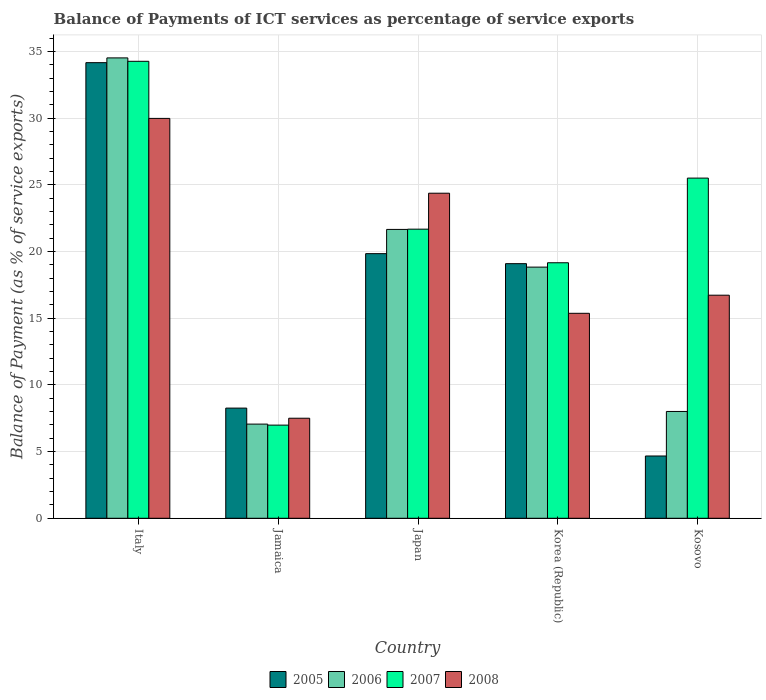How many different coloured bars are there?
Make the answer very short. 4. Are the number of bars on each tick of the X-axis equal?
Keep it short and to the point. Yes. How many bars are there on the 5th tick from the right?
Offer a terse response. 4. What is the label of the 1st group of bars from the left?
Your answer should be very brief. Italy. What is the balance of payments of ICT services in 2008 in Kosovo?
Ensure brevity in your answer.  16.73. Across all countries, what is the maximum balance of payments of ICT services in 2007?
Offer a terse response. 34.28. Across all countries, what is the minimum balance of payments of ICT services in 2005?
Keep it short and to the point. 4.67. In which country was the balance of payments of ICT services in 2006 maximum?
Make the answer very short. Italy. In which country was the balance of payments of ICT services in 2007 minimum?
Make the answer very short. Jamaica. What is the total balance of payments of ICT services in 2008 in the graph?
Your response must be concise. 93.99. What is the difference between the balance of payments of ICT services in 2007 in Jamaica and that in Korea (Republic)?
Provide a short and direct response. -12.18. What is the difference between the balance of payments of ICT services in 2008 in Japan and the balance of payments of ICT services in 2006 in Italy?
Your answer should be compact. -10.15. What is the average balance of payments of ICT services in 2005 per country?
Your response must be concise. 17.21. What is the difference between the balance of payments of ICT services of/in 2006 and balance of payments of ICT services of/in 2005 in Japan?
Offer a terse response. 1.82. In how many countries, is the balance of payments of ICT services in 2007 greater than 16 %?
Keep it short and to the point. 4. What is the ratio of the balance of payments of ICT services in 2005 in Jamaica to that in Japan?
Your answer should be very brief. 0.42. Is the difference between the balance of payments of ICT services in 2006 in Japan and Kosovo greater than the difference between the balance of payments of ICT services in 2005 in Japan and Kosovo?
Provide a succinct answer. No. What is the difference between the highest and the second highest balance of payments of ICT services in 2008?
Your answer should be compact. 7.65. What is the difference between the highest and the lowest balance of payments of ICT services in 2005?
Provide a succinct answer. 29.5. Is the sum of the balance of payments of ICT services in 2006 in Japan and Kosovo greater than the maximum balance of payments of ICT services in 2007 across all countries?
Your response must be concise. No. Is it the case that in every country, the sum of the balance of payments of ICT services in 2005 and balance of payments of ICT services in 2008 is greater than the sum of balance of payments of ICT services in 2007 and balance of payments of ICT services in 2006?
Your response must be concise. No. How many countries are there in the graph?
Your answer should be compact. 5. What is the difference between two consecutive major ticks on the Y-axis?
Make the answer very short. 5. Does the graph contain any zero values?
Your answer should be compact. No. Does the graph contain grids?
Ensure brevity in your answer.  Yes. Where does the legend appear in the graph?
Make the answer very short. Bottom center. How are the legend labels stacked?
Give a very brief answer. Horizontal. What is the title of the graph?
Your answer should be very brief. Balance of Payments of ICT services as percentage of service exports. What is the label or title of the Y-axis?
Your answer should be very brief. Balance of Payment (as % of service exports). What is the Balance of Payment (as % of service exports) in 2005 in Italy?
Ensure brevity in your answer.  34.17. What is the Balance of Payment (as % of service exports) of 2006 in Italy?
Offer a very short reply. 34.53. What is the Balance of Payment (as % of service exports) of 2007 in Italy?
Make the answer very short. 34.28. What is the Balance of Payment (as % of service exports) in 2008 in Italy?
Ensure brevity in your answer.  29.99. What is the Balance of Payment (as % of service exports) in 2005 in Jamaica?
Give a very brief answer. 8.26. What is the Balance of Payment (as % of service exports) in 2006 in Jamaica?
Provide a succinct answer. 7.06. What is the Balance of Payment (as % of service exports) of 2007 in Jamaica?
Offer a very short reply. 6.99. What is the Balance of Payment (as % of service exports) in 2008 in Jamaica?
Offer a very short reply. 7.5. What is the Balance of Payment (as % of service exports) of 2005 in Japan?
Ensure brevity in your answer.  19.85. What is the Balance of Payment (as % of service exports) of 2006 in Japan?
Provide a short and direct response. 21.67. What is the Balance of Payment (as % of service exports) of 2007 in Japan?
Provide a succinct answer. 21.69. What is the Balance of Payment (as % of service exports) of 2008 in Japan?
Offer a terse response. 24.38. What is the Balance of Payment (as % of service exports) in 2005 in Korea (Republic)?
Offer a very short reply. 19.1. What is the Balance of Payment (as % of service exports) in 2006 in Korea (Republic)?
Provide a short and direct response. 18.84. What is the Balance of Payment (as % of service exports) of 2007 in Korea (Republic)?
Provide a short and direct response. 19.16. What is the Balance of Payment (as % of service exports) in 2008 in Korea (Republic)?
Your answer should be very brief. 15.37. What is the Balance of Payment (as % of service exports) of 2005 in Kosovo?
Your answer should be compact. 4.67. What is the Balance of Payment (as % of service exports) of 2006 in Kosovo?
Your answer should be very brief. 8.01. What is the Balance of Payment (as % of service exports) in 2007 in Kosovo?
Your response must be concise. 25.51. What is the Balance of Payment (as % of service exports) in 2008 in Kosovo?
Keep it short and to the point. 16.73. Across all countries, what is the maximum Balance of Payment (as % of service exports) of 2005?
Give a very brief answer. 34.17. Across all countries, what is the maximum Balance of Payment (as % of service exports) in 2006?
Make the answer very short. 34.53. Across all countries, what is the maximum Balance of Payment (as % of service exports) in 2007?
Your answer should be compact. 34.28. Across all countries, what is the maximum Balance of Payment (as % of service exports) in 2008?
Offer a very short reply. 29.99. Across all countries, what is the minimum Balance of Payment (as % of service exports) in 2005?
Your answer should be very brief. 4.67. Across all countries, what is the minimum Balance of Payment (as % of service exports) of 2006?
Provide a succinct answer. 7.06. Across all countries, what is the minimum Balance of Payment (as % of service exports) of 2007?
Your response must be concise. 6.99. Across all countries, what is the minimum Balance of Payment (as % of service exports) in 2008?
Keep it short and to the point. 7.5. What is the total Balance of Payment (as % of service exports) in 2005 in the graph?
Offer a very short reply. 86.05. What is the total Balance of Payment (as % of service exports) of 2006 in the graph?
Make the answer very short. 90.11. What is the total Balance of Payment (as % of service exports) in 2007 in the graph?
Offer a terse response. 107.63. What is the total Balance of Payment (as % of service exports) in 2008 in the graph?
Your answer should be very brief. 93.99. What is the difference between the Balance of Payment (as % of service exports) of 2005 in Italy and that in Jamaica?
Provide a succinct answer. 25.91. What is the difference between the Balance of Payment (as % of service exports) in 2006 in Italy and that in Jamaica?
Provide a short and direct response. 27.47. What is the difference between the Balance of Payment (as % of service exports) in 2007 in Italy and that in Jamaica?
Offer a terse response. 27.29. What is the difference between the Balance of Payment (as % of service exports) of 2008 in Italy and that in Jamaica?
Provide a succinct answer. 22.49. What is the difference between the Balance of Payment (as % of service exports) of 2005 in Italy and that in Japan?
Provide a succinct answer. 14.33. What is the difference between the Balance of Payment (as % of service exports) of 2006 in Italy and that in Japan?
Provide a short and direct response. 12.87. What is the difference between the Balance of Payment (as % of service exports) of 2007 in Italy and that in Japan?
Make the answer very short. 12.59. What is the difference between the Balance of Payment (as % of service exports) in 2008 in Italy and that in Japan?
Keep it short and to the point. 5.61. What is the difference between the Balance of Payment (as % of service exports) in 2005 in Italy and that in Korea (Republic)?
Provide a short and direct response. 15.08. What is the difference between the Balance of Payment (as % of service exports) of 2006 in Italy and that in Korea (Republic)?
Make the answer very short. 15.69. What is the difference between the Balance of Payment (as % of service exports) in 2007 in Italy and that in Korea (Republic)?
Your response must be concise. 15.11. What is the difference between the Balance of Payment (as % of service exports) in 2008 in Italy and that in Korea (Republic)?
Give a very brief answer. 14.62. What is the difference between the Balance of Payment (as % of service exports) of 2005 in Italy and that in Kosovo?
Your response must be concise. 29.5. What is the difference between the Balance of Payment (as % of service exports) of 2006 in Italy and that in Kosovo?
Offer a very short reply. 26.52. What is the difference between the Balance of Payment (as % of service exports) of 2007 in Italy and that in Kosovo?
Offer a very short reply. 8.76. What is the difference between the Balance of Payment (as % of service exports) of 2008 in Italy and that in Kosovo?
Keep it short and to the point. 13.26. What is the difference between the Balance of Payment (as % of service exports) in 2005 in Jamaica and that in Japan?
Make the answer very short. -11.59. What is the difference between the Balance of Payment (as % of service exports) in 2006 in Jamaica and that in Japan?
Offer a very short reply. -14.6. What is the difference between the Balance of Payment (as % of service exports) of 2007 in Jamaica and that in Japan?
Provide a short and direct response. -14.7. What is the difference between the Balance of Payment (as % of service exports) of 2008 in Jamaica and that in Japan?
Offer a very short reply. -16.88. What is the difference between the Balance of Payment (as % of service exports) in 2005 in Jamaica and that in Korea (Republic)?
Your answer should be very brief. -10.83. What is the difference between the Balance of Payment (as % of service exports) in 2006 in Jamaica and that in Korea (Republic)?
Give a very brief answer. -11.78. What is the difference between the Balance of Payment (as % of service exports) of 2007 in Jamaica and that in Korea (Republic)?
Your answer should be compact. -12.18. What is the difference between the Balance of Payment (as % of service exports) in 2008 in Jamaica and that in Korea (Republic)?
Provide a succinct answer. -7.87. What is the difference between the Balance of Payment (as % of service exports) in 2005 in Jamaica and that in Kosovo?
Your answer should be compact. 3.59. What is the difference between the Balance of Payment (as % of service exports) of 2006 in Jamaica and that in Kosovo?
Your answer should be very brief. -0.95. What is the difference between the Balance of Payment (as % of service exports) in 2007 in Jamaica and that in Kosovo?
Keep it short and to the point. -18.53. What is the difference between the Balance of Payment (as % of service exports) of 2008 in Jamaica and that in Kosovo?
Your answer should be very brief. -9.23. What is the difference between the Balance of Payment (as % of service exports) in 2005 in Japan and that in Korea (Republic)?
Keep it short and to the point. 0.75. What is the difference between the Balance of Payment (as % of service exports) of 2006 in Japan and that in Korea (Republic)?
Offer a very short reply. 2.83. What is the difference between the Balance of Payment (as % of service exports) in 2007 in Japan and that in Korea (Republic)?
Ensure brevity in your answer.  2.52. What is the difference between the Balance of Payment (as % of service exports) in 2008 in Japan and that in Korea (Republic)?
Your answer should be very brief. 9.01. What is the difference between the Balance of Payment (as % of service exports) of 2005 in Japan and that in Kosovo?
Provide a succinct answer. 15.18. What is the difference between the Balance of Payment (as % of service exports) of 2006 in Japan and that in Kosovo?
Your response must be concise. 13.66. What is the difference between the Balance of Payment (as % of service exports) in 2007 in Japan and that in Kosovo?
Ensure brevity in your answer.  -3.83. What is the difference between the Balance of Payment (as % of service exports) of 2008 in Japan and that in Kosovo?
Make the answer very short. 7.65. What is the difference between the Balance of Payment (as % of service exports) in 2005 in Korea (Republic) and that in Kosovo?
Provide a succinct answer. 14.43. What is the difference between the Balance of Payment (as % of service exports) in 2006 in Korea (Republic) and that in Kosovo?
Keep it short and to the point. 10.83. What is the difference between the Balance of Payment (as % of service exports) of 2007 in Korea (Republic) and that in Kosovo?
Your answer should be compact. -6.35. What is the difference between the Balance of Payment (as % of service exports) in 2008 in Korea (Republic) and that in Kosovo?
Give a very brief answer. -1.36. What is the difference between the Balance of Payment (as % of service exports) in 2005 in Italy and the Balance of Payment (as % of service exports) in 2006 in Jamaica?
Your answer should be compact. 27.11. What is the difference between the Balance of Payment (as % of service exports) in 2005 in Italy and the Balance of Payment (as % of service exports) in 2007 in Jamaica?
Your answer should be very brief. 27.19. What is the difference between the Balance of Payment (as % of service exports) in 2005 in Italy and the Balance of Payment (as % of service exports) in 2008 in Jamaica?
Your answer should be very brief. 26.67. What is the difference between the Balance of Payment (as % of service exports) in 2006 in Italy and the Balance of Payment (as % of service exports) in 2007 in Jamaica?
Ensure brevity in your answer.  27.54. What is the difference between the Balance of Payment (as % of service exports) of 2006 in Italy and the Balance of Payment (as % of service exports) of 2008 in Jamaica?
Ensure brevity in your answer.  27.03. What is the difference between the Balance of Payment (as % of service exports) of 2007 in Italy and the Balance of Payment (as % of service exports) of 2008 in Jamaica?
Your response must be concise. 26.77. What is the difference between the Balance of Payment (as % of service exports) in 2005 in Italy and the Balance of Payment (as % of service exports) in 2006 in Japan?
Offer a terse response. 12.51. What is the difference between the Balance of Payment (as % of service exports) of 2005 in Italy and the Balance of Payment (as % of service exports) of 2007 in Japan?
Provide a short and direct response. 12.49. What is the difference between the Balance of Payment (as % of service exports) of 2005 in Italy and the Balance of Payment (as % of service exports) of 2008 in Japan?
Provide a short and direct response. 9.79. What is the difference between the Balance of Payment (as % of service exports) of 2006 in Italy and the Balance of Payment (as % of service exports) of 2007 in Japan?
Offer a terse response. 12.85. What is the difference between the Balance of Payment (as % of service exports) of 2006 in Italy and the Balance of Payment (as % of service exports) of 2008 in Japan?
Offer a very short reply. 10.15. What is the difference between the Balance of Payment (as % of service exports) of 2007 in Italy and the Balance of Payment (as % of service exports) of 2008 in Japan?
Your answer should be compact. 9.89. What is the difference between the Balance of Payment (as % of service exports) in 2005 in Italy and the Balance of Payment (as % of service exports) in 2006 in Korea (Republic)?
Offer a terse response. 15.34. What is the difference between the Balance of Payment (as % of service exports) of 2005 in Italy and the Balance of Payment (as % of service exports) of 2007 in Korea (Republic)?
Your answer should be very brief. 15.01. What is the difference between the Balance of Payment (as % of service exports) of 2005 in Italy and the Balance of Payment (as % of service exports) of 2008 in Korea (Republic)?
Your answer should be very brief. 18.8. What is the difference between the Balance of Payment (as % of service exports) in 2006 in Italy and the Balance of Payment (as % of service exports) in 2007 in Korea (Republic)?
Ensure brevity in your answer.  15.37. What is the difference between the Balance of Payment (as % of service exports) in 2006 in Italy and the Balance of Payment (as % of service exports) in 2008 in Korea (Republic)?
Your answer should be compact. 19.16. What is the difference between the Balance of Payment (as % of service exports) of 2007 in Italy and the Balance of Payment (as % of service exports) of 2008 in Korea (Republic)?
Offer a very short reply. 18.9. What is the difference between the Balance of Payment (as % of service exports) in 2005 in Italy and the Balance of Payment (as % of service exports) in 2006 in Kosovo?
Offer a terse response. 26.16. What is the difference between the Balance of Payment (as % of service exports) in 2005 in Italy and the Balance of Payment (as % of service exports) in 2007 in Kosovo?
Keep it short and to the point. 8.66. What is the difference between the Balance of Payment (as % of service exports) in 2005 in Italy and the Balance of Payment (as % of service exports) in 2008 in Kosovo?
Ensure brevity in your answer.  17.44. What is the difference between the Balance of Payment (as % of service exports) of 2006 in Italy and the Balance of Payment (as % of service exports) of 2007 in Kosovo?
Provide a succinct answer. 9.02. What is the difference between the Balance of Payment (as % of service exports) of 2006 in Italy and the Balance of Payment (as % of service exports) of 2008 in Kosovo?
Provide a short and direct response. 17.8. What is the difference between the Balance of Payment (as % of service exports) in 2007 in Italy and the Balance of Payment (as % of service exports) in 2008 in Kosovo?
Offer a terse response. 17.54. What is the difference between the Balance of Payment (as % of service exports) in 2005 in Jamaica and the Balance of Payment (as % of service exports) in 2006 in Japan?
Your answer should be compact. -13.4. What is the difference between the Balance of Payment (as % of service exports) of 2005 in Jamaica and the Balance of Payment (as % of service exports) of 2007 in Japan?
Offer a very short reply. -13.42. What is the difference between the Balance of Payment (as % of service exports) of 2005 in Jamaica and the Balance of Payment (as % of service exports) of 2008 in Japan?
Offer a terse response. -16.12. What is the difference between the Balance of Payment (as % of service exports) in 2006 in Jamaica and the Balance of Payment (as % of service exports) in 2007 in Japan?
Keep it short and to the point. -14.62. What is the difference between the Balance of Payment (as % of service exports) in 2006 in Jamaica and the Balance of Payment (as % of service exports) in 2008 in Japan?
Offer a terse response. -17.32. What is the difference between the Balance of Payment (as % of service exports) of 2007 in Jamaica and the Balance of Payment (as % of service exports) of 2008 in Japan?
Your answer should be very brief. -17.39. What is the difference between the Balance of Payment (as % of service exports) of 2005 in Jamaica and the Balance of Payment (as % of service exports) of 2006 in Korea (Republic)?
Make the answer very short. -10.58. What is the difference between the Balance of Payment (as % of service exports) in 2005 in Jamaica and the Balance of Payment (as % of service exports) in 2007 in Korea (Republic)?
Provide a short and direct response. -10.9. What is the difference between the Balance of Payment (as % of service exports) of 2005 in Jamaica and the Balance of Payment (as % of service exports) of 2008 in Korea (Republic)?
Offer a terse response. -7.11. What is the difference between the Balance of Payment (as % of service exports) of 2006 in Jamaica and the Balance of Payment (as % of service exports) of 2007 in Korea (Republic)?
Make the answer very short. -12.1. What is the difference between the Balance of Payment (as % of service exports) in 2006 in Jamaica and the Balance of Payment (as % of service exports) in 2008 in Korea (Republic)?
Keep it short and to the point. -8.31. What is the difference between the Balance of Payment (as % of service exports) of 2007 in Jamaica and the Balance of Payment (as % of service exports) of 2008 in Korea (Republic)?
Your answer should be very brief. -8.39. What is the difference between the Balance of Payment (as % of service exports) in 2005 in Jamaica and the Balance of Payment (as % of service exports) in 2006 in Kosovo?
Your answer should be compact. 0.25. What is the difference between the Balance of Payment (as % of service exports) of 2005 in Jamaica and the Balance of Payment (as % of service exports) of 2007 in Kosovo?
Your answer should be compact. -17.25. What is the difference between the Balance of Payment (as % of service exports) of 2005 in Jamaica and the Balance of Payment (as % of service exports) of 2008 in Kosovo?
Keep it short and to the point. -8.47. What is the difference between the Balance of Payment (as % of service exports) in 2006 in Jamaica and the Balance of Payment (as % of service exports) in 2007 in Kosovo?
Offer a very short reply. -18.45. What is the difference between the Balance of Payment (as % of service exports) of 2006 in Jamaica and the Balance of Payment (as % of service exports) of 2008 in Kosovo?
Your answer should be very brief. -9.67. What is the difference between the Balance of Payment (as % of service exports) in 2007 in Jamaica and the Balance of Payment (as % of service exports) in 2008 in Kosovo?
Your answer should be very brief. -9.74. What is the difference between the Balance of Payment (as % of service exports) of 2005 in Japan and the Balance of Payment (as % of service exports) of 2006 in Korea (Republic)?
Provide a short and direct response. 1.01. What is the difference between the Balance of Payment (as % of service exports) of 2005 in Japan and the Balance of Payment (as % of service exports) of 2007 in Korea (Republic)?
Provide a short and direct response. 0.68. What is the difference between the Balance of Payment (as % of service exports) in 2005 in Japan and the Balance of Payment (as % of service exports) in 2008 in Korea (Republic)?
Provide a short and direct response. 4.48. What is the difference between the Balance of Payment (as % of service exports) of 2006 in Japan and the Balance of Payment (as % of service exports) of 2007 in Korea (Republic)?
Offer a very short reply. 2.5. What is the difference between the Balance of Payment (as % of service exports) in 2006 in Japan and the Balance of Payment (as % of service exports) in 2008 in Korea (Republic)?
Provide a succinct answer. 6.29. What is the difference between the Balance of Payment (as % of service exports) of 2007 in Japan and the Balance of Payment (as % of service exports) of 2008 in Korea (Republic)?
Give a very brief answer. 6.31. What is the difference between the Balance of Payment (as % of service exports) in 2005 in Japan and the Balance of Payment (as % of service exports) in 2006 in Kosovo?
Your response must be concise. 11.84. What is the difference between the Balance of Payment (as % of service exports) in 2005 in Japan and the Balance of Payment (as % of service exports) in 2007 in Kosovo?
Your answer should be compact. -5.67. What is the difference between the Balance of Payment (as % of service exports) of 2005 in Japan and the Balance of Payment (as % of service exports) of 2008 in Kosovo?
Your answer should be compact. 3.12. What is the difference between the Balance of Payment (as % of service exports) of 2006 in Japan and the Balance of Payment (as % of service exports) of 2007 in Kosovo?
Your answer should be compact. -3.85. What is the difference between the Balance of Payment (as % of service exports) of 2006 in Japan and the Balance of Payment (as % of service exports) of 2008 in Kosovo?
Provide a short and direct response. 4.93. What is the difference between the Balance of Payment (as % of service exports) of 2007 in Japan and the Balance of Payment (as % of service exports) of 2008 in Kosovo?
Your answer should be compact. 4.95. What is the difference between the Balance of Payment (as % of service exports) in 2005 in Korea (Republic) and the Balance of Payment (as % of service exports) in 2006 in Kosovo?
Your answer should be compact. 11.09. What is the difference between the Balance of Payment (as % of service exports) of 2005 in Korea (Republic) and the Balance of Payment (as % of service exports) of 2007 in Kosovo?
Your answer should be very brief. -6.42. What is the difference between the Balance of Payment (as % of service exports) of 2005 in Korea (Republic) and the Balance of Payment (as % of service exports) of 2008 in Kosovo?
Offer a terse response. 2.37. What is the difference between the Balance of Payment (as % of service exports) in 2006 in Korea (Republic) and the Balance of Payment (as % of service exports) in 2007 in Kosovo?
Your answer should be very brief. -6.68. What is the difference between the Balance of Payment (as % of service exports) in 2006 in Korea (Republic) and the Balance of Payment (as % of service exports) in 2008 in Kosovo?
Provide a short and direct response. 2.11. What is the difference between the Balance of Payment (as % of service exports) of 2007 in Korea (Republic) and the Balance of Payment (as % of service exports) of 2008 in Kosovo?
Provide a short and direct response. 2.43. What is the average Balance of Payment (as % of service exports) of 2005 per country?
Make the answer very short. 17.21. What is the average Balance of Payment (as % of service exports) of 2006 per country?
Offer a very short reply. 18.02. What is the average Balance of Payment (as % of service exports) of 2007 per country?
Make the answer very short. 21.53. What is the average Balance of Payment (as % of service exports) of 2008 per country?
Your answer should be very brief. 18.8. What is the difference between the Balance of Payment (as % of service exports) in 2005 and Balance of Payment (as % of service exports) in 2006 in Italy?
Your answer should be compact. -0.36. What is the difference between the Balance of Payment (as % of service exports) in 2005 and Balance of Payment (as % of service exports) in 2007 in Italy?
Ensure brevity in your answer.  -0.1. What is the difference between the Balance of Payment (as % of service exports) in 2005 and Balance of Payment (as % of service exports) in 2008 in Italy?
Ensure brevity in your answer.  4.18. What is the difference between the Balance of Payment (as % of service exports) in 2006 and Balance of Payment (as % of service exports) in 2007 in Italy?
Ensure brevity in your answer.  0.26. What is the difference between the Balance of Payment (as % of service exports) in 2006 and Balance of Payment (as % of service exports) in 2008 in Italy?
Provide a short and direct response. 4.54. What is the difference between the Balance of Payment (as % of service exports) in 2007 and Balance of Payment (as % of service exports) in 2008 in Italy?
Your answer should be compact. 4.28. What is the difference between the Balance of Payment (as % of service exports) in 2005 and Balance of Payment (as % of service exports) in 2006 in Jamaica?
Ensure brevity in your answer.  1.2. What is the difference between the Balance of Payment (as % of service exports) of 2005 and Balance of Payment (as % of service exports) of 2007 in Jamaica?
Ensure brevity in your answer.  1.28. What is the difference between the Balance of Payment (as % of service exports) in 2005 and Balance of Payment (as % of service exports) in 2008 in Jamaica?
Provide a succinct answer. 0.76. What is the difference between the Balance of Payment (as % of service exports) of 2006 and Balance of Payment (as % of service exports) of 2007 in Jamaica?
Offer a very short reply. 0.08. What is the difference between the Balance of Payment (as % of service exports) of 2006 and Balance of Payment (as % of service exports) of 2008 in Jamaica?
Your response must be concise. -0.44. What is the difference between the Balance of Payment (as % of service exports) of 2007 and Balance of Payment (as % of service exports) of 2008 in Jamaica?
Give a very brief answer. -0.52. What is the difference between the Balance of Payment (as % of service exports) of 2005 and Balance of Payment (as % of service exports) of 2006 in Japan?
Provide a succinct answer. -1.82. What is the difference between the Balance of Payment (as % of service exports) of 2005 and Balance of Payment (as % of service exports) of 2007 in Japan?
Offer a terse response. -1.84. What is the difference between the Balance of Payment (as % of service exports) of 2005 and Balance of Payment (as % of service exports) of 2008 in Japan?
Make the answer very short. -4.53. What is the difference between the Balance of Payment (as % of service exports) in 2006 and Balance of Payment (as % of service exports) in 2007 in Japan?
Your answer should be compact. -0.02. What is the difference between the Balance of Payment (as % of service exports) in 2006 and Balance of Payment (as % of service exports) in 2008 in Japan?
Your answer should be compact. -2.72. What is the difference between the Balance of Payment (as % of service exports) of 2007 and Balance of Payment (as % of service exports) of 2008 in Japan?
Provide a succinct answer. -2.7. What is the difference between the Balance of Payment (as % of service exports) in 2005 and Balance of Payment (as % of service exports) in 2006 in Korea (Republic)?
Provide a succinct answer. 0.26. What is the difference between the Balance of Payment (as % of service exports) of 2005 and Balance of Payment (as % of service exports) of 2007 in Korea (Republic)?
Provide a succinct answer. -0.07. What is the difference between the Balance of Payment (as % of service exports) in 2005 and Balance of Payment (as % of service exports) in 2008 in Korea (Republic)?
Make the answer very short. 3.72. What is the difference between the Balance of Payment (as % of service exports) in 2006 and Balance of Payment (as % of service exports) in 2007 in Korea (Republic)?
Your answer should be very brief. -0.33. What is the difference between the Balance of Payment (as % of service exports) of 2006 and Balance of Payment (as % of service exports) of 2008 in Korea (Republic)?
Provide a succinct answer. 3.46. What is the difference between the Balance of Payment (as % of service exports) of 2007 and Balance of Payment (as % of service exports) of 2008 in Korea (Republic)?
Your answer should be very brief. 3.79. What is the difference between the Balance of Payment (as % of service exports) of 2005 and Balance of Payment (as % of service exports) of 2006 in Kosovo?
Your answer should be compact. -3.34. What is the difference between the Balance of Payment (as % of service exports) of 2005 and Balance of Payment (as % of service exports) of 2007 in Kosovo?
Your answer should be very brief. -20.84. What is the difference between the Balance of Payment (as % of service exports) in 2005 and Balance of Payment (as % of service exports) in 2008 in Kosovo?
Provide a short and direct response. -12.06. What is the difference between the Balance of Payment (as % of service exports) in 2006 and Balance of Payment (as % of service exports) in 2007 in Kosovo?
Your answer should be very brief. -17.5. What is the difference between the Balance of Payment (as % of service exports) of 2006 and Balance of Payment (as % of service exports) of 2008 in Kosovo?
Your answer should be compact. -8.72. What is the difference between the Balance of Payment (as % of service exports) in 2007 and Balance of Payment (as % of service exports) in 2008 in Kosovo?
Your response must be concise. 8.78. What is the ratio of the Balance of Payment (as % of service exports) of 2005 in Italy to that in Jamaica?
Offer a terse response. 4.14. What is the ratio of the Balance of Payment (as % of service exports) of 2006 in Italy to that in Jamaica?
Ensure brevity in your answer.  4.89. What is the ratio of the Balance of Payment (as % of service exports) in 2007 in Italy to that in Jamaica?
Your answer should be very brief. 4.91. What is the ratio of the Balance of Payment (as % of service exports) of 2008 in Italy to that in Jamaica?
Your answer should be compact. 4. What is the ratio of the Balance of Payment (as % of service exports) in 2005 in Italy to that in Japan?
Your answer should be very brief. 1.72. What is the ratio of the Balance of Payment (as % of service exports) of 2006 in Italy to that in Japan?
Ensure brevity in your answer.  1.59. What is the ratio of the Balance of Payment (as % of service exports) in 2007 in Italy to that in Japan?
Your response must be concise. 1.58. What is the ratio of the Balance of Payment (as % of service exports) of 2008 in Italy to that in Japan?
Keep it short and to the point. 1.23. What is the ratio of the Balance of Payment (as % of service exports) of 2005 in Italy to that in Korea (Republic)?
Your answer should be compact. 1.79. What is the ratio of the Balance of Payment (as % of service exports) in 2006 in Italy to that in Korea (Republic)?
Provide a short and direct response. 1.83. What is the ratio of the Balance of Payment (as % of service exports) in 2007 in Italy to that in Korea (Republic)?
Provide a succinct answer. 1.79. What is the ratio of the Balance of Payment (as % of service exports) of 2008 in Italy to that in Korea (Republic)?
Your response must be concise. 1.95. What is the ratio of the Balance of Payment (as % of service exports) of 2005 in Italy to that in Kosovo?
Keep it short and to the point. 7.32. What is the ratio of the Balance of Payment (as % of service exports) of 2006 in Italy to that in Kosovo?
Your response must be concise. 4.31. What is the ratio of the Balance of Payment (as % of service exports) of 2007 in Italy to that in Kosovo?
Offer a very short reply. 1.34. What is the ratio of the Balance of Payment (as % of service exports) of 2008 in Italy to that in Kosovo?
Give a very brief answer. 1.79. What is the ratio of the Balance of Payment (as % of service exports) of 2005 in Jamaica to that in Japan?
Keep it short and to the point. 0.42. What is the ratio of the Balance of Payment (as % of service exports) of 2006 in Jamaica to that in Japan?
Keep it short and to the point. 0.33. What is the ratio of the Balance of Payment (as % of service exports) in 2007 in Jamaica to that in Japan?
Provide a short and direct response. 0.32. What is the ratio of the Balance of Payment (as % of service exports) of 2008 in Jamaica to that in Japan?
Your answer should be compact. 0.31. What is the ratio of the Balance of Payment (as % of service exports) in 2005 in Jamaica to that in Korea (Republic)?
Provide a succinct answer. 0.43. What is the ratio of the Balance of Payment (as % of service exports) of 2006 in Jamaica to that in Korea (Republic)?
Give a very brief answer. 0.37. What is the ratio of the Balance of Payment (as % of service exports) of 2007 in Jamaica to that in Korea (Republic)?
Make the answer very short. 0.36. What is the ratio of the Balance of Payment (as % of service exports) in 2008 in Jamaica to that in Korea (Republic)?
Give a very brief answer. 0.49. What is the ratio of the Balance of Payment (as % of service exports) of 2005 in Jamaica to that in Kosovo?
Your answer should be very brief. 1.77. What is the ratio of the Balance of Payment (as % of service exports) in 2006 in Jamaica to that in Kosovo?
Your answer should be compact. 0.88. What is the ratio of the Balance of Payment (as % of service exports) in 2007 in Jamaica to that in Kosovo?
Offer a very short reply. 0.27. What is the ratio of the Balance of Payment (as % of service exports) of 2008 in Jamaica to that in Kosovo?
Your response must be concise. 0.45. What is the ratio of the Balance of Payment (as % of service exports) of 2005 in Japan to that in Korea (Republic)?
Offer a terse response. 1.04. What is the ratio of the Balance of Payment (as % of service exports) in 2006 in Japan to that in Korea (Republic)?
Offer a terse response. 1.15. What is the ratio of the Balance of Payment (as % of service exports) in 2007 in Japan to that in Korea (Republic)?
Make the answer very short. 1.13. What is the ratio of the Balance of Payment (as % of service exports) in 2008 in Japan to that in Korea (Republic)?
Give a very brief answer. 1.59. What is the ratio of the Balance of Payment (as % of service exports) in 2005 in Japan to that in Kosovo?
Make the answer very short. 4.25. What is the ratio of the Balance of Payment (as % of service exports) in 2006 in Japan to that in Kosovo?
Offer a very short reply. 2.7. What is the ratio of the Balance of Payment (as % of service exports) of 2007 in Japan to that in Kosovo?
Ensure brevity in your answer.  0.85. What is the ratio of the Balance of Payment (as % of service exports) in 2008 in Japan to that in Kosovo?
Your answer should be compact. 1.46. What is the ratio of the Balance of Payment (as % of service exports) of 2005 in Korea (Republic) to that in Kosovo?
Offer a terse response. 4.09. What is the ratio of the Balance of Payment (as % of service exports) in 2006 in Korea (Republic) to that in Kosovo?
Provide a short and direct response. 2.35. What is the ratio of the Balance of Payment (as % of service exports) in 2007 in Korea (Republic) to that in Kosovo?
Offer a terse response. 0.75. What is the ratio of the Balance of Payment (as % of service exports) of 2008 in Korea (Republic) to that in Kosovo?
Provide a short and direct response. 0.92. What is the difference between the highest and the second highest Balance of Payment (as % of service exports) in 2005?
Give a very brief answer. 14.33. What is the difference between the highest and the second highest Balance of Payment (as % of service exports) of 2006?
Your response must be concise. 12.87. What is the difference between the highest and the second highest Balance of Payment (as % of service exports) in 2007?
Make the answer very short. 8.76. What is the difference between the highest and the second highest Balance of Payment (as % of service exports) of 2008?
Make the answer very short. 5.61. What is the difference between the highest and the lowest Balance of Payment (as % of service exports) of 2005?
Offer a very short reply. 29.5. What is the difference between the highest and the lowest Balance of Payment (as % of service exports) of 2006?
Provide a short and direct response. 27.47. What is the difference between the highest and the lowest Balance of Payment (as % of service exports) in 2007?
Provide a short and direct response. 27.29. What is the difference between the highest and the lowest Balance of Payment (as % of service exports) in 2008?
Ensure brevity in your answer.  22.49. 